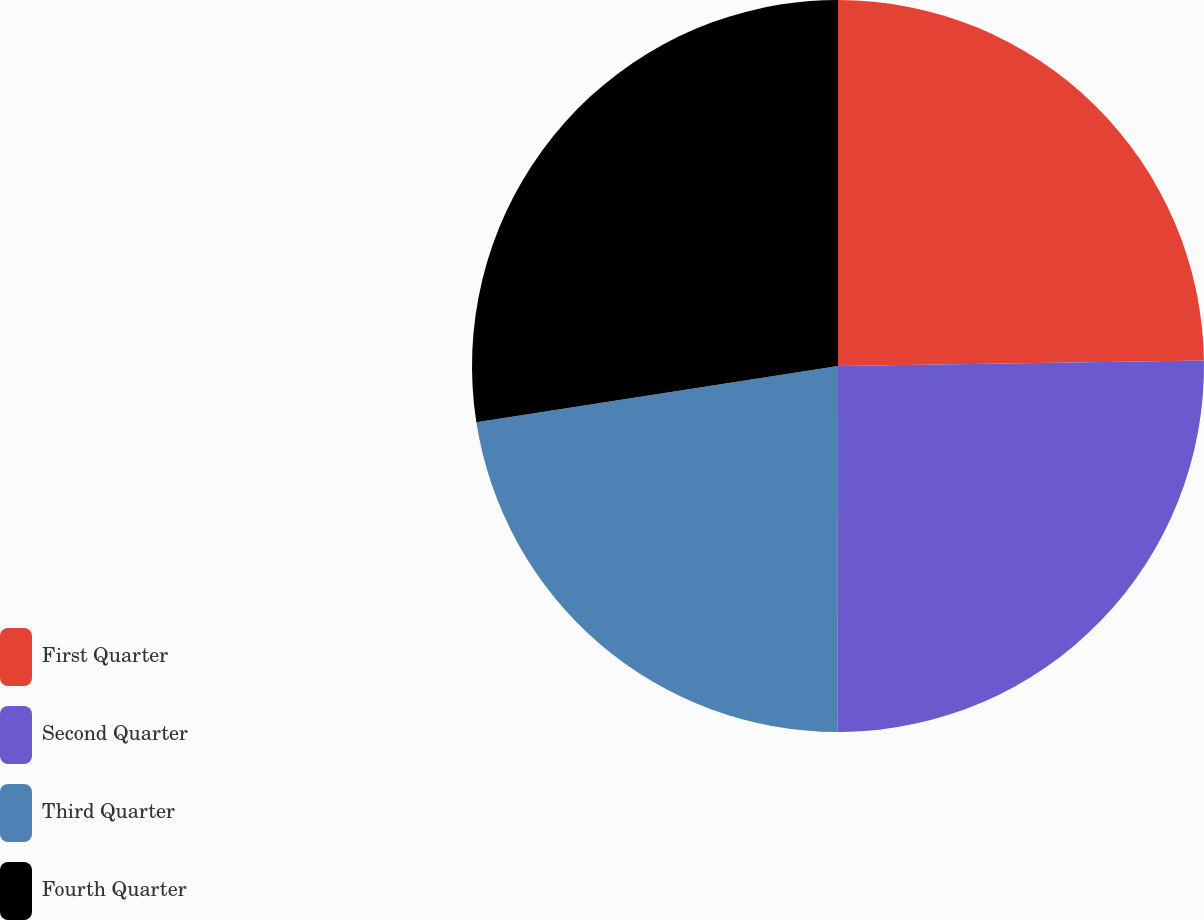Convert chart. <chart><loc_0><loc_0><loc_500><loc_500><pie_chart><fcel>First Quarter<fcel>Second Quarter<fcel>Third Quarter<fcel>Fourth Quarter<nl><fcel>24.76%<fcel>25.25%<fcel>22.53%<fcel>27.46%<nl></chart> 